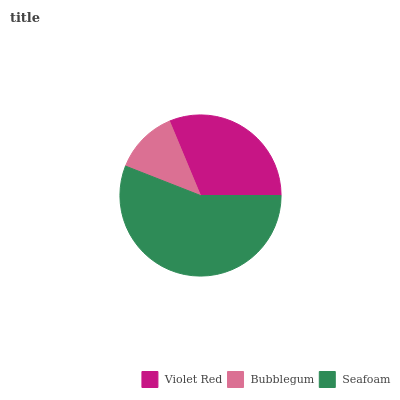Is Bubblegum the minimum?
Answer yes or no. Yes. Is Seafoam the maximum?
Answer yes or no. Yes. Is Seafoam the minimum?
Answer yes or no. No. Is Bubblegum the maximum?
Answer yes or no. No. Is Seafoam greater than Bubblegum?
Answer yes or no. Yes. Is Bubblegum less than Seafoam?
Answer yes or no. Yes. Is Bubblegum greater than Seafoam?
Answer yes or no. No. Is Seafoam less than Bubblegum?
Answer yes or no. No. Is Violet Red the high median?
Answer yes or no. Yes. Is Violet Red the low median?
Answer yes or no. Yes. Is Seafoam the high median?
Answer yes or no. No. Is Seafoam the low median?
Answer yes or no. No. 